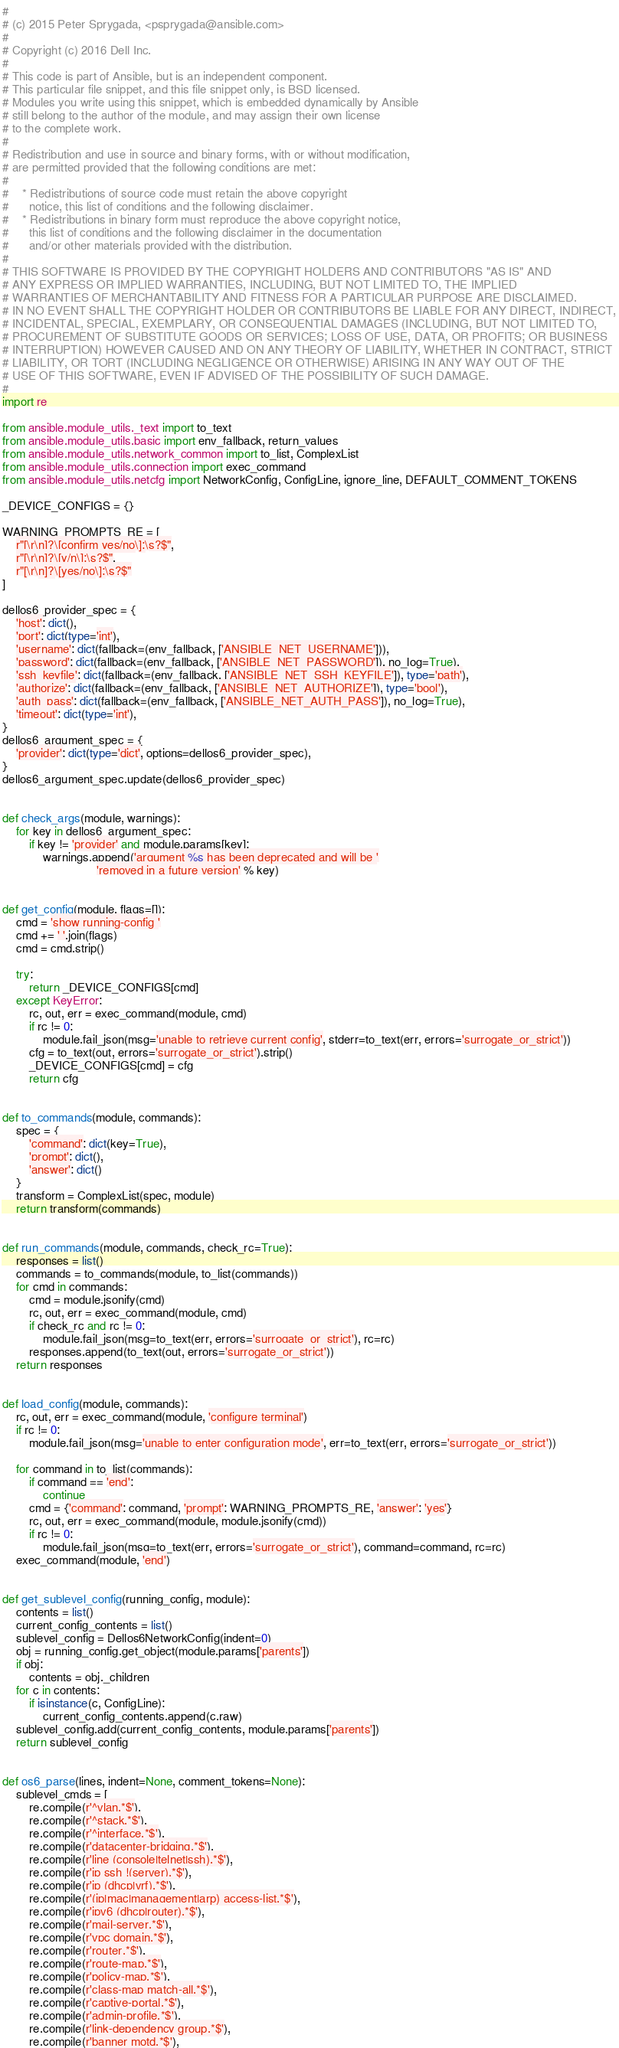<code> <loc_0><loc_0><loc_500><loc_500><_Python_>#
# (c) 2015 Peter Sprygada, <psprygada@ansible.com>
#
# Copyright (c) 2016 Dell Inc.
#
# This code is part of Ansible, but is an independent component.
# This particular file snippet, and this file snippet only, is BSD licensed.
# Modules you write using this snippet, which is embedded dynamically by Ansible
# still belong to the author of the module, and may assign their own license
# to the complete work.
#
# Redistribution and use in source and binary forms, with or without modification,
# are permitted provided that the following conditions are met:
#
#    * Redistributions of source code must retain the above copyright
#      notice, this list of conditions and the following disclaimer.
#    * Redistributions in binary form must reproduce the above copyright notice,
#      this list of conditions and the following disclaimer in the documentation
#      and/or other materials provided with the distribution.
#
# THIS SOFTWARE IS PROVIDED BY THE COPYRIGHT HOLDERS AND CONTRIBUTORS "AS IS" AND
# ANY EXPRESS OR IMPLIED WARRANTIES, INCLUDING, BUT NOT LIMITED TO, THE IMPLIED
# WARRANTIES OF MERCHANTABILITY AND FITNESS FOR A PARTICULAR PURPOSE ARE DISCLAIMED.
# IN NO EVENT SHALL THE COPYRIGHT HOLDER OR CONTRIBUTORS BE LIABLE FOR ANY DIRECT, INDIRECT,
# INCIDENTAL, SPECIAL, EXEMPLARY, OR CONSEQUENTIAL DAMAGES (INCLUDING, BUT NOT LIMITED TO,
# PROCUREMENT OF SUBSTITUTE GOODS OR SERVICES; LOSS OF USE, DATA, OR PROFITS; OR BUSINESS
# INTERRUPTION) HOWEVER CAUSED AND ON ANY THEORY OF LIABILITY, WHETHER IN CONTRACT, STRICT
# LIABILITY, OR TORT (INCLUDING NEGLIGENCE OR OTHERWISE) ARISING IN ANY WAY OUT OF THE
# USE OF THIS SOFTWARE, EVEN IF ADVISED OF THE POSSIBILITY OF SUCH DAMAGE.
#
import re

from ansible.module_utils._text import to_text
from ansible.module_utils.basic import env_fallback, return_values
from ansible.module_utils.network_common import to_list, ComplexList
from ansible.module_utils.connection import exec_command
from ansible.module_utils.netcfg import NetworkConfig, ConfigLine, ignore_line, DEFAULT_COMMENT_TOKENS

_DEVICE_CONFIGS = {}

WARNING_PROMPTS_RE = [
    r"[\r\n]?\[confirm yes/no\]:\s?$",
    r"[\r\n]?\[y/n\]:\s?$",
    r"[\r\n]?\[yes/no\]:\s?$"
]

dellos6_provider_spec = {
    'host': dict(),
    'port': dict(type='int'),
    'username': dict(fallback=(env_fallback, ['ANSIBLE_NET_USERNAME'])),
    'password': dict(fallback=(env_fallback, ['ANSIBLE_NET_PASSWORD']), no_log=True),
    'ssh_keyfile': dict(fallback=(env_fallback, ['ANSIBLE_NET_SSH_KEYFILE']), type='path'),
    'authorize': dict(fallback=(env_fallback, ['ANSIBLE_NET_AUTHORIZE']), type='bool'),
    'auth_pass': dict(fallback=(env_fallback, ['ANSIBLE_NET_AUTH_PASS']), no_log=True),
    'timeout': dict(type='int'),
}
dellos6_argument_spec = {
    'provider': dict(type='dict', options=dellos6_provider_spec),
}
dellos6_argument_spec.update(dellos6_provider_spec)


def check_args(module, warnings):
    for key in dellos6_argument_spec:
        if key != 'provider' and module.params[key]:
            warnings.append('argument %s has been deprecated and will be '
                            'removed in a future version' % key)


def get_config(module, flags=[]):
    cmd = 'show running-config '
    cmd += ' '.join(flags)
    cmd = cmd.strip()

    try:
        return _DEVICE_CONFIGS[cmd]
    except KeyError:
        rc, out, err = exec_command(module, cmd)
        if rc != 0:
            module.fail_json(msg='unable to retrieve current config', stderr=to_text(err, errors='surrogate_or_strict'))
        cfg = to_text(out, errors='surrogate_or_strict').strip()
        _DEVICE_CONFIGS[cmd] = cfg
        return cfg


def to_commands(module, commands):
    spec = {
        'command': dict(key=True),
        'prompt': dict(),
        'answer': dict()
    }
    transform = ComplexList(spec, module)
    return transform(commands)


def run_commands(module, commands, check_rc=True):
    responses = list()
    commands = to_commands(module, to_list(commands))
    for cmd in commands:
        cmd = module.jsonify(cmd)
        rc, out, err = exec_command(module, cmd)
        if check_rc and rc != 0:
            module.fail_json(msg=to_text(err, errors='surrogate_or_strict'), rc=rc)
        responses.append(to_text(out, errors='surrogate_or_strict'))
    return responses


def load_config(module, commands):
    rc, out, err = exec_command(module, 'configure terminal')
    if rc != 0:
        module.fail_json(msg='unable to enter configuration mode', err=to_text(err, errors='surrogate_or_strict'))

    for command in to_list(commands):
        if command == 'end':
            continue
        cmd = {'command': command, 'prompt': WARNING_PROMPTS_RE, 'answer': 'yes'}
        rc, out, err = exec_command(module, module.jsonify(cmd))
        if rc != 0:
            module.fail_json(msg=to_text(err, errors='surrogate_or_strict'), command=command, rc=rc)
    exec_command(module, 'end')


def get_sublevel_config(running_config, module):
    contents = list()
    current_config_contents = list()
    sublevel_config = Dellos6NetworkConfig(indent=0)
    obj = running_config.get_object(module.params['parents'])
    if obj:
        contents = obj._children
    for c in contents:
        if isinstance(c, ConfigLine):
            current_config_contents.append(c.raw)
    sublevel_config.add(current_config_contents, module.params['parents'])
    return sublevel_config


def os6_parse(lines, indent=None, comment_tokens=None):
    sublevel_cmds = [
        re.compile(r'^vlan.*$'),
        re.compile(r'^stack.*$'),
        re.compile(r'^interface.*$'),
        re.compile(r'datacenter-bridging.*$'),
        re.compile(r'line (console|telnet|ssh).*$'),
        re.compile(r'ip ssh !(server).*$'),
        re.compile(r'ip (dhcp|vrf).*$'),
        re.compile(r'(ip|mac|management|arp) access-list.*$'),
        re.compile(r'ipv6 (dhcp|router).*$'),
        re.compile(r'mail-server.*$'),
        re.compile(r'vpc domain.*$'),
        re.compile(r'router.*$'),
        re.compile(r'route-map.*$'),
        re.compile(r'policy-map.*$'),
        re.compile(r'class-map match-all.*$'),
        re.compile(r'captive-portal.*$'),
        re.compile(r'admin-profile.*$'),
        re.compile(r'link-dependency group.*$'),
        re.compile(r'banner motd.*$'),</code> 